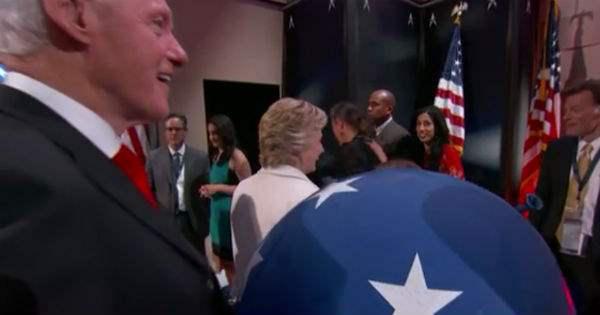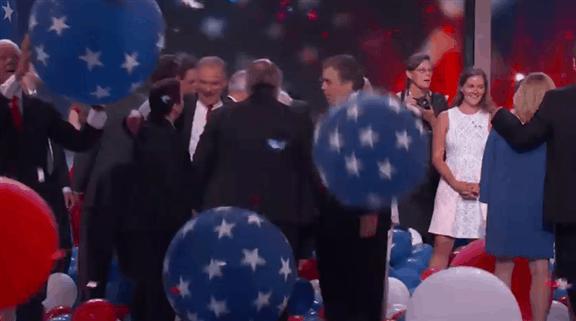The first image is the image on the left, the second image is the image on the right. Evaluate the accuracy of this statement regarding the images: "A white haired man is playing with red, white and blue balloons.". Is it true? Answer yes or no. No. The first image is the image on the left, the second image is the image on the right. Evaluate the accuracy of this statement regarding the images: "In at least one image the president his holding a single blue balloon with stars.". Is it true? Answer yes or no. Yes. 